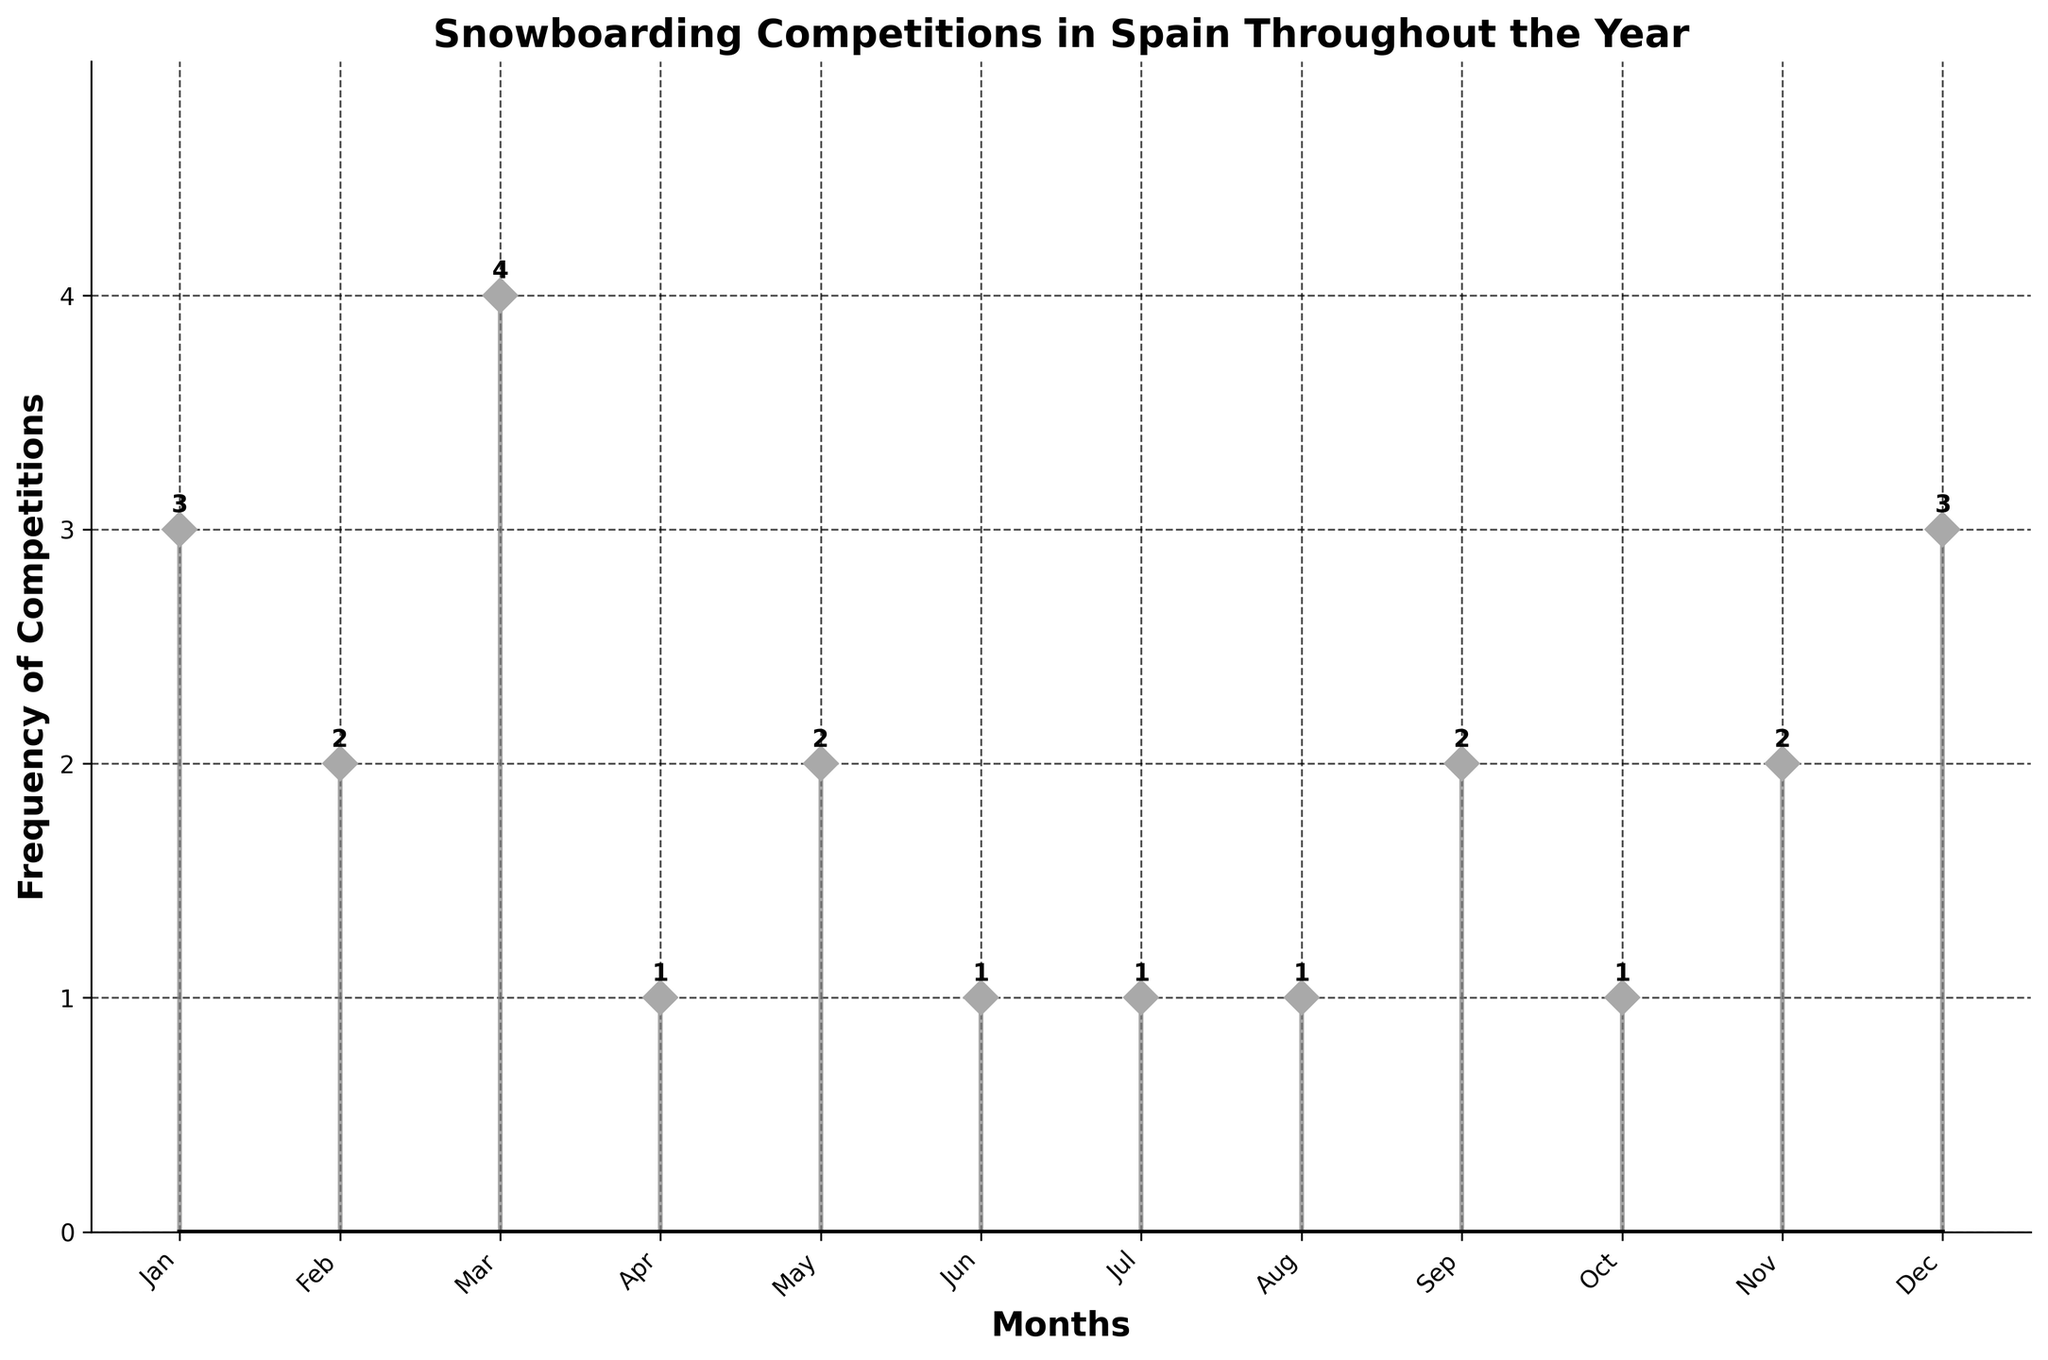Which month has the highest frequency of snowboarding competitions? The stem plot shows the month of March has the highest data point representing 4 competitions.
Answer: March What is the total number of snowboarding competitions from January to December? Adding the frequencies from each month: 3 (Jan) + 2 (Feb) + 4 (Mar) + 1 (Apr) + 2 (May) + 1 (Jun) + 1 (Jul) + 1 (Aug) + 2 (Sep) + 1 (Oct) + 2 (Nov) + 3 (Dec) = 23
Answer: 23 Which months have exactly 2 snowboarding competitions? The stem plot shows the months with data points at the level 2 are February, May, September, and November.
Answer: February, May, September, November How many months have only one snowboarding competition? Counting the data points that are at the level 1: April, June, July, August, October. There are five months.
Answer: 5 Are there any months without any snowboarding competitions? All the months from January to December have at least one data point above zero, indicating they all have snowboarding competitions.
Answer: No Comparing January and December, which month has more snowboarding competitions and by how much? January has 3 competitions whereas December also has 3 competitions, so both months have the same number of competitions.
Answer: They are equal What is the average number of snowboarding competitions per month? The total number of competitions is 23. Dividing this by 12 months gives an average of 23 / 12 ≈ 1.92.
Answer: 1.92 Which quarter of the year (1st, 2nd, 3rd, or 4th) has the highest total frequency of competitions? Sum of frequencies per quarter: Q1 (Jan-Mar) = 9, Q2 (Apr-Jun) = 4, Q3 (Jul-Sep) = 4, Q4 (Oct-Dec) = 6. The first quarter has the highest total frequency.
Answer: 1st Is there a pattern in the distribution of snowboarding competitions throughout the year? The plot shows a higher concentration of competitions in winter months (Jan-Mar) and again in December, with fewer competitions in the middle of the year (summer months).
Answer: Higher in winter and December 